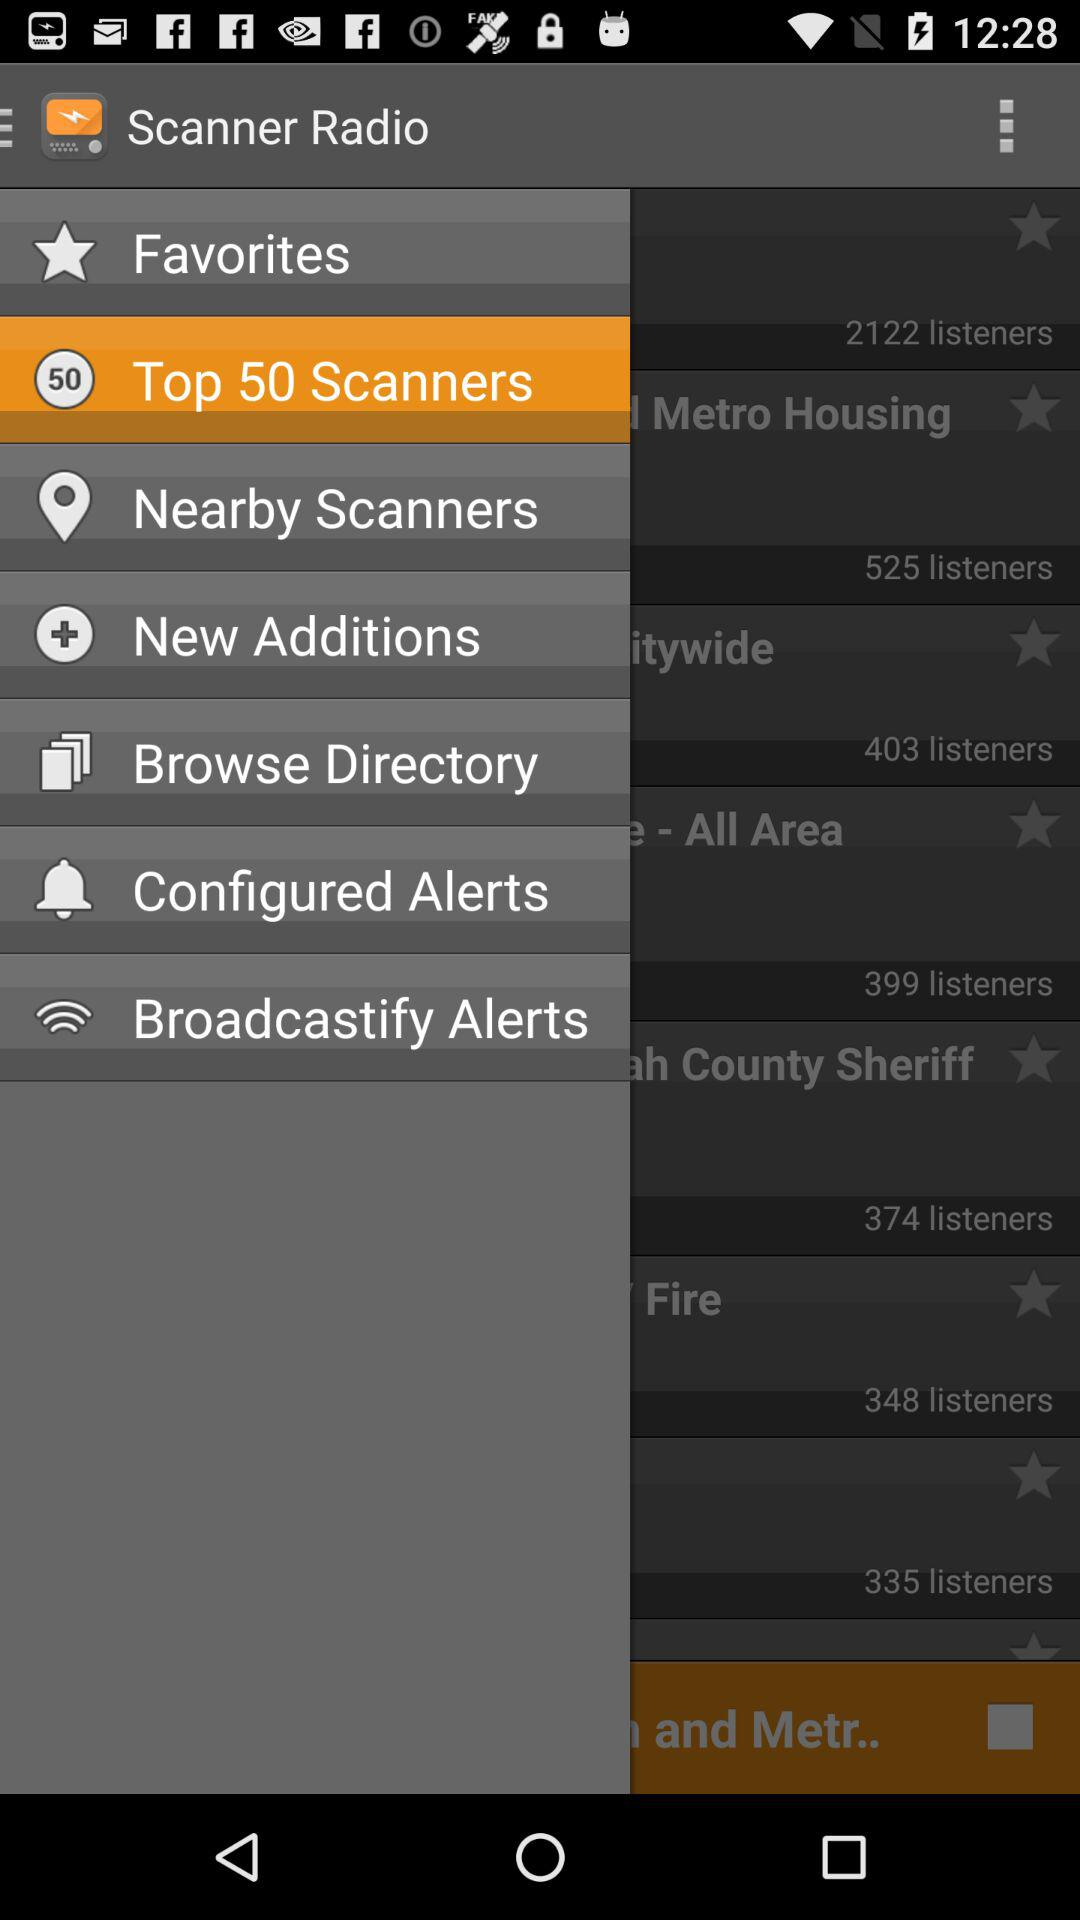What is the count of top scanners? The count is 50. 